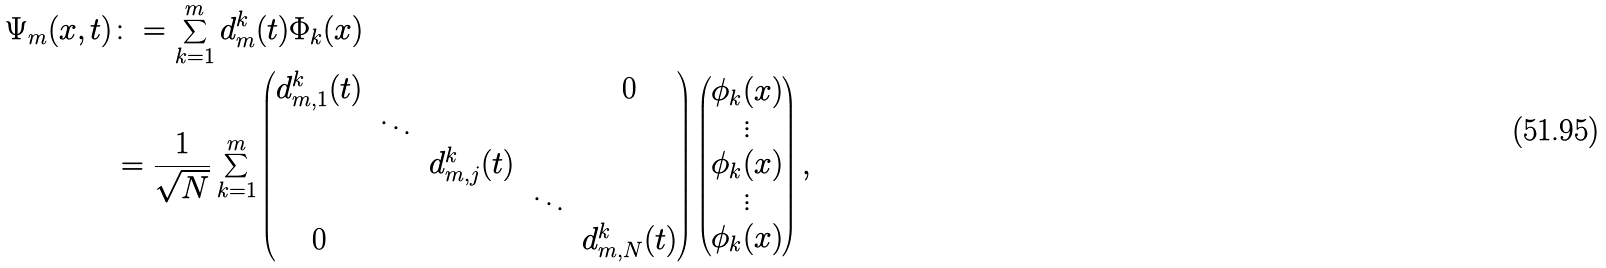Convert formula to latex. <formula><loc_0><loc_0><loc_500><loc_500>\Psi _ { m } ( x , t ) & \colon = \sum _ { k = 1 } ^ { m } d ^ { k } _ { m } ( t ) \Phi _ { k } ( x ) \\ & = \frac { 1 } { \sqrt { N } } \sum _ { k = 1 } ^ { m } \begin{pmatrix} d _ { m , 1 } ^ { k } ( t ) & & & & 0 \\ & \ddots \\ & & d _ { m , j } ^ { k } ( t ) \\ & & & \ddots \\ 0 & & & & d _ { m , N } ^ { k } ( t ) \end{pmatrix} \begin{pmatrix} \phi _ { k } ( x ) \\ \vdots \\ \phi _ { k } ( x ) \\ \vdots \\ \phi _ { k } ( x ) \end{pmatrix} ,</formula> 